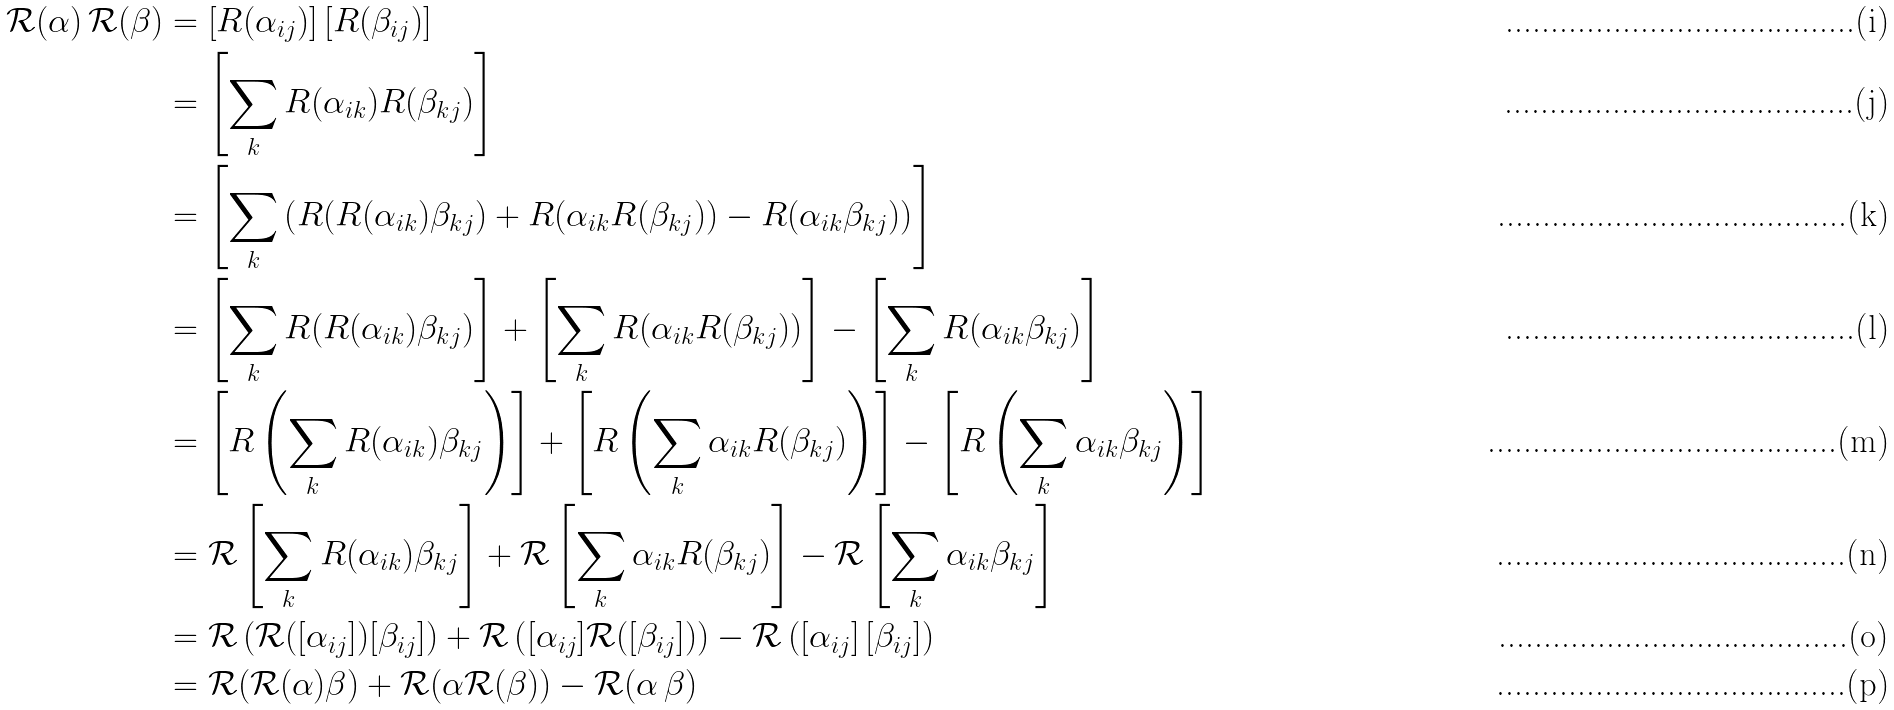<formula> <loc_0><loc_0><loc_500><loc_500>\mathcal { R } ( \alpha ) \, \mathcal { R } ( \beta ) & = \left [ R ( \alpha _ { i j } ) \right ] \left [ R ( \beta _ { i j } ) \right ] \\ & = \left [ \sum _ { k } R ( \alpha _ { i k } ) R ( \beta _ { k j } ) \right ] \\ & = \left [ \sum _ { k } \left ( R ( R ( \alpha _ { i k } ) \beta _ { k j } ) + R ( \alpha _ { i k } R ( \beta _ { k j } ) ) - R ( \alpha _ { i k } \beta _ { k j } ) \right ) \right ] \\ & = \left [ \sum _ { k } R ( R ( \alpha _ { i k } ) \beta _ { k j } ) \right ] + \left [ \sum _ { k } R ( \alpha _ { i k } R ( \beta _ { k j } ) ) \right ] - \left [ \sum _ { k } R ( \alpha _ { i k } \beta _ { k j } ) \right ] \\ & = \left [ R \left ( \sum _ { k } R ( \alpha _ { i k } ) \beta _ { k j } \right ) \right ] + \left [ R \left ( \sum _ { k } \alpha _ { i k } R ( \beta _ { k j } ) \right ) \right ] - \left [ R \left ( \sum _ { k } \alpha _ { i k } \beta _ { k j } \right ) \right ] \\ & = \mathcal { R } \left [ \sum _ { k } R ( \alpha _ { i k } ) \beta _ { k j } \right ] + \mathcal { R } \left [ \sum _ { k } \alpha _ { i k } R ( \beta _ { k j } ) \right ] - \mathcal { R } \left [ \sum _ { k } \alpha _ { i k } \beta _ { k j } \right ] \\ & = \mathcal { R } \left ( \mathcal { R } ( [ \alpha _ { i j } ] ) [ \beta _ { i j } ] \right ) + \mathcal { R } \left ( [ \alpha _ { i j } ] \mathcal { R } ( [ \beta _ { i j } ] ) \right ) - \mathcal { R } \left ( \left [ \alpha _ { i j } \right ] \left [ \beta _ { i j } \right ] \right ) \\ & = \mathcal { R } ( \mathcal { R } ( \alpha ) \beta ) + \mathcal { R } ( \alpha \mathcal { R } ( \beta ) ) - \mathcal { R } ( \alpha \, \beta )</formula> 